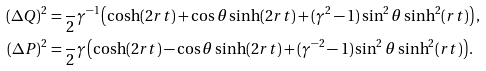<formula> <loc_0><loc_0><loc_500><loc_500>( \Delta Q ) ^ { 2 } & = \frac { } { 2 } \gamma ^ { - 1 } \left ( \cosh ( 2 r t ) + \cos \theta \sinh ( 2 r t ) + ( \gamma ^ { 2 } - 1 ) \sin ^ { 2 } \theta \sinh ^ { 2 } ( r t ) \right ) , \\ ( \Delta P ) ^ { 2 } & = \frac { } { 2 } \gamma \left ( \cosh ( 2 r t ) - \cos \theta \sinh ( 2 r t ) + ( \gamma ^ { - 2 } - 1 ) \sin ^ { 2 } \theta \sinh ^ { 2 } ( r t ) \right ) .</formula> 